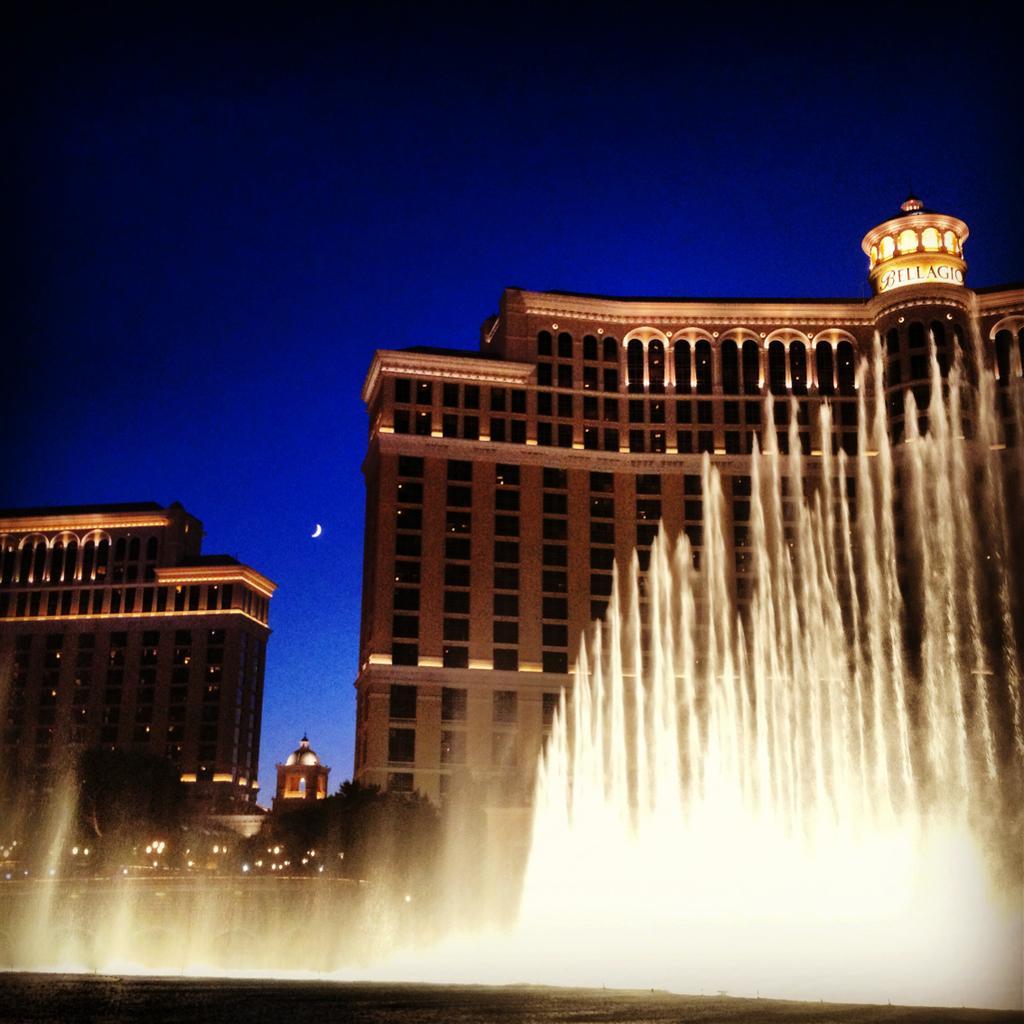How would you summarize this image in a sentence or two? In front of the image there is a fountain. There are trees, buildings, lights. At the top of the image there is a moon in the sky. 